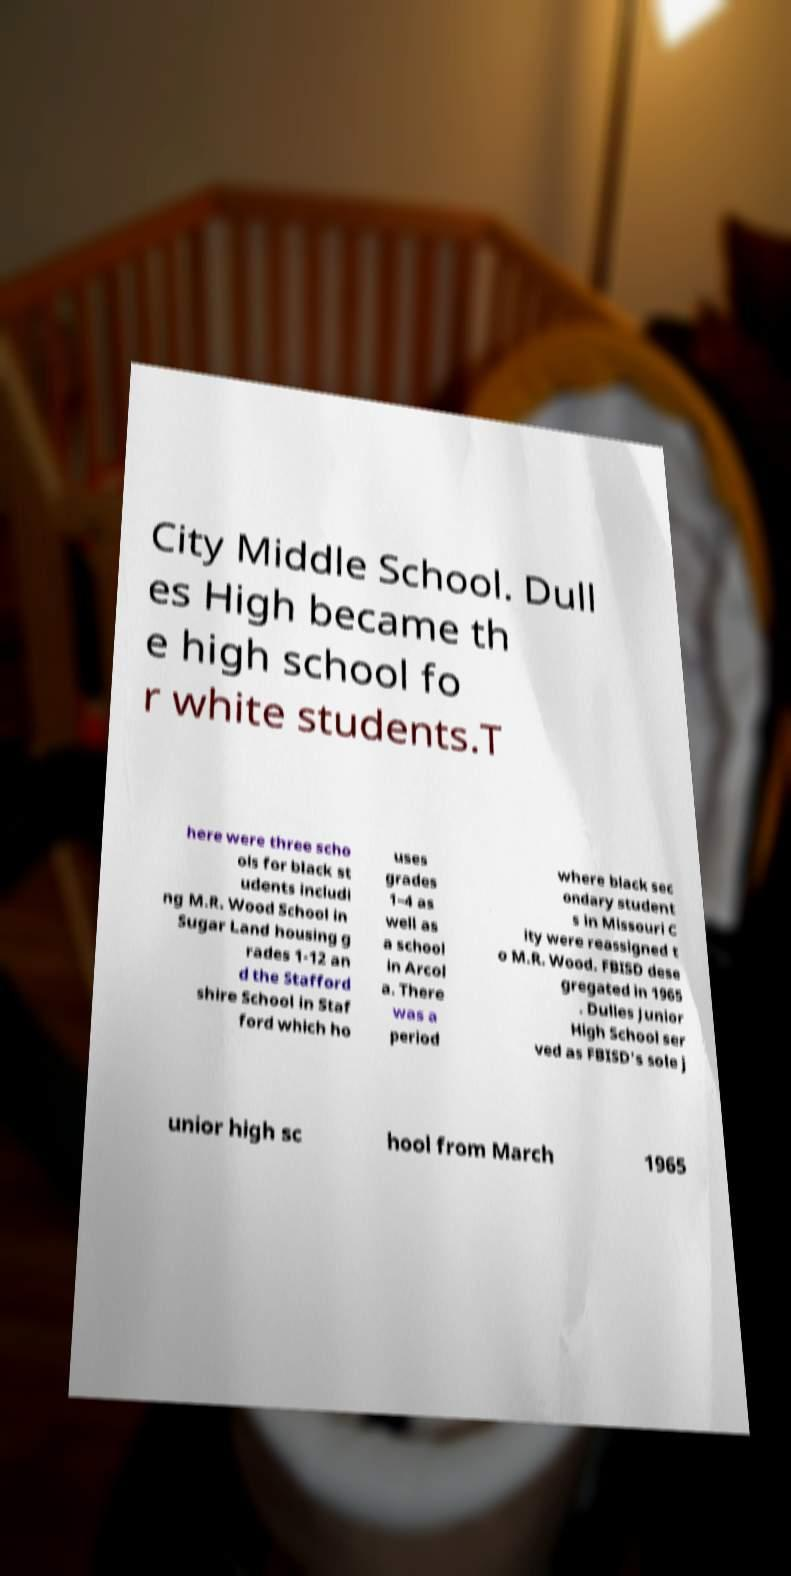Please read and relay the text visible in this image. What does it say? City Middle School. Dull es High became th e high school fo r white students.T here were three scho ols for black st udents includi ng M.R. Wood School in Sugar Land housing g rades 1-12 an d the Stafford shire School in Staf ford which ho uses grades 1–4 as well as a school in Arcol a. There was a period where black sec ondary student s in Missouri C ity were reassigned t o M.R. Wood. FBISD dese gregated in 1965 . Dulles Junior High School ser ved as FBISD's sole j unior high sc hool from March 1965 